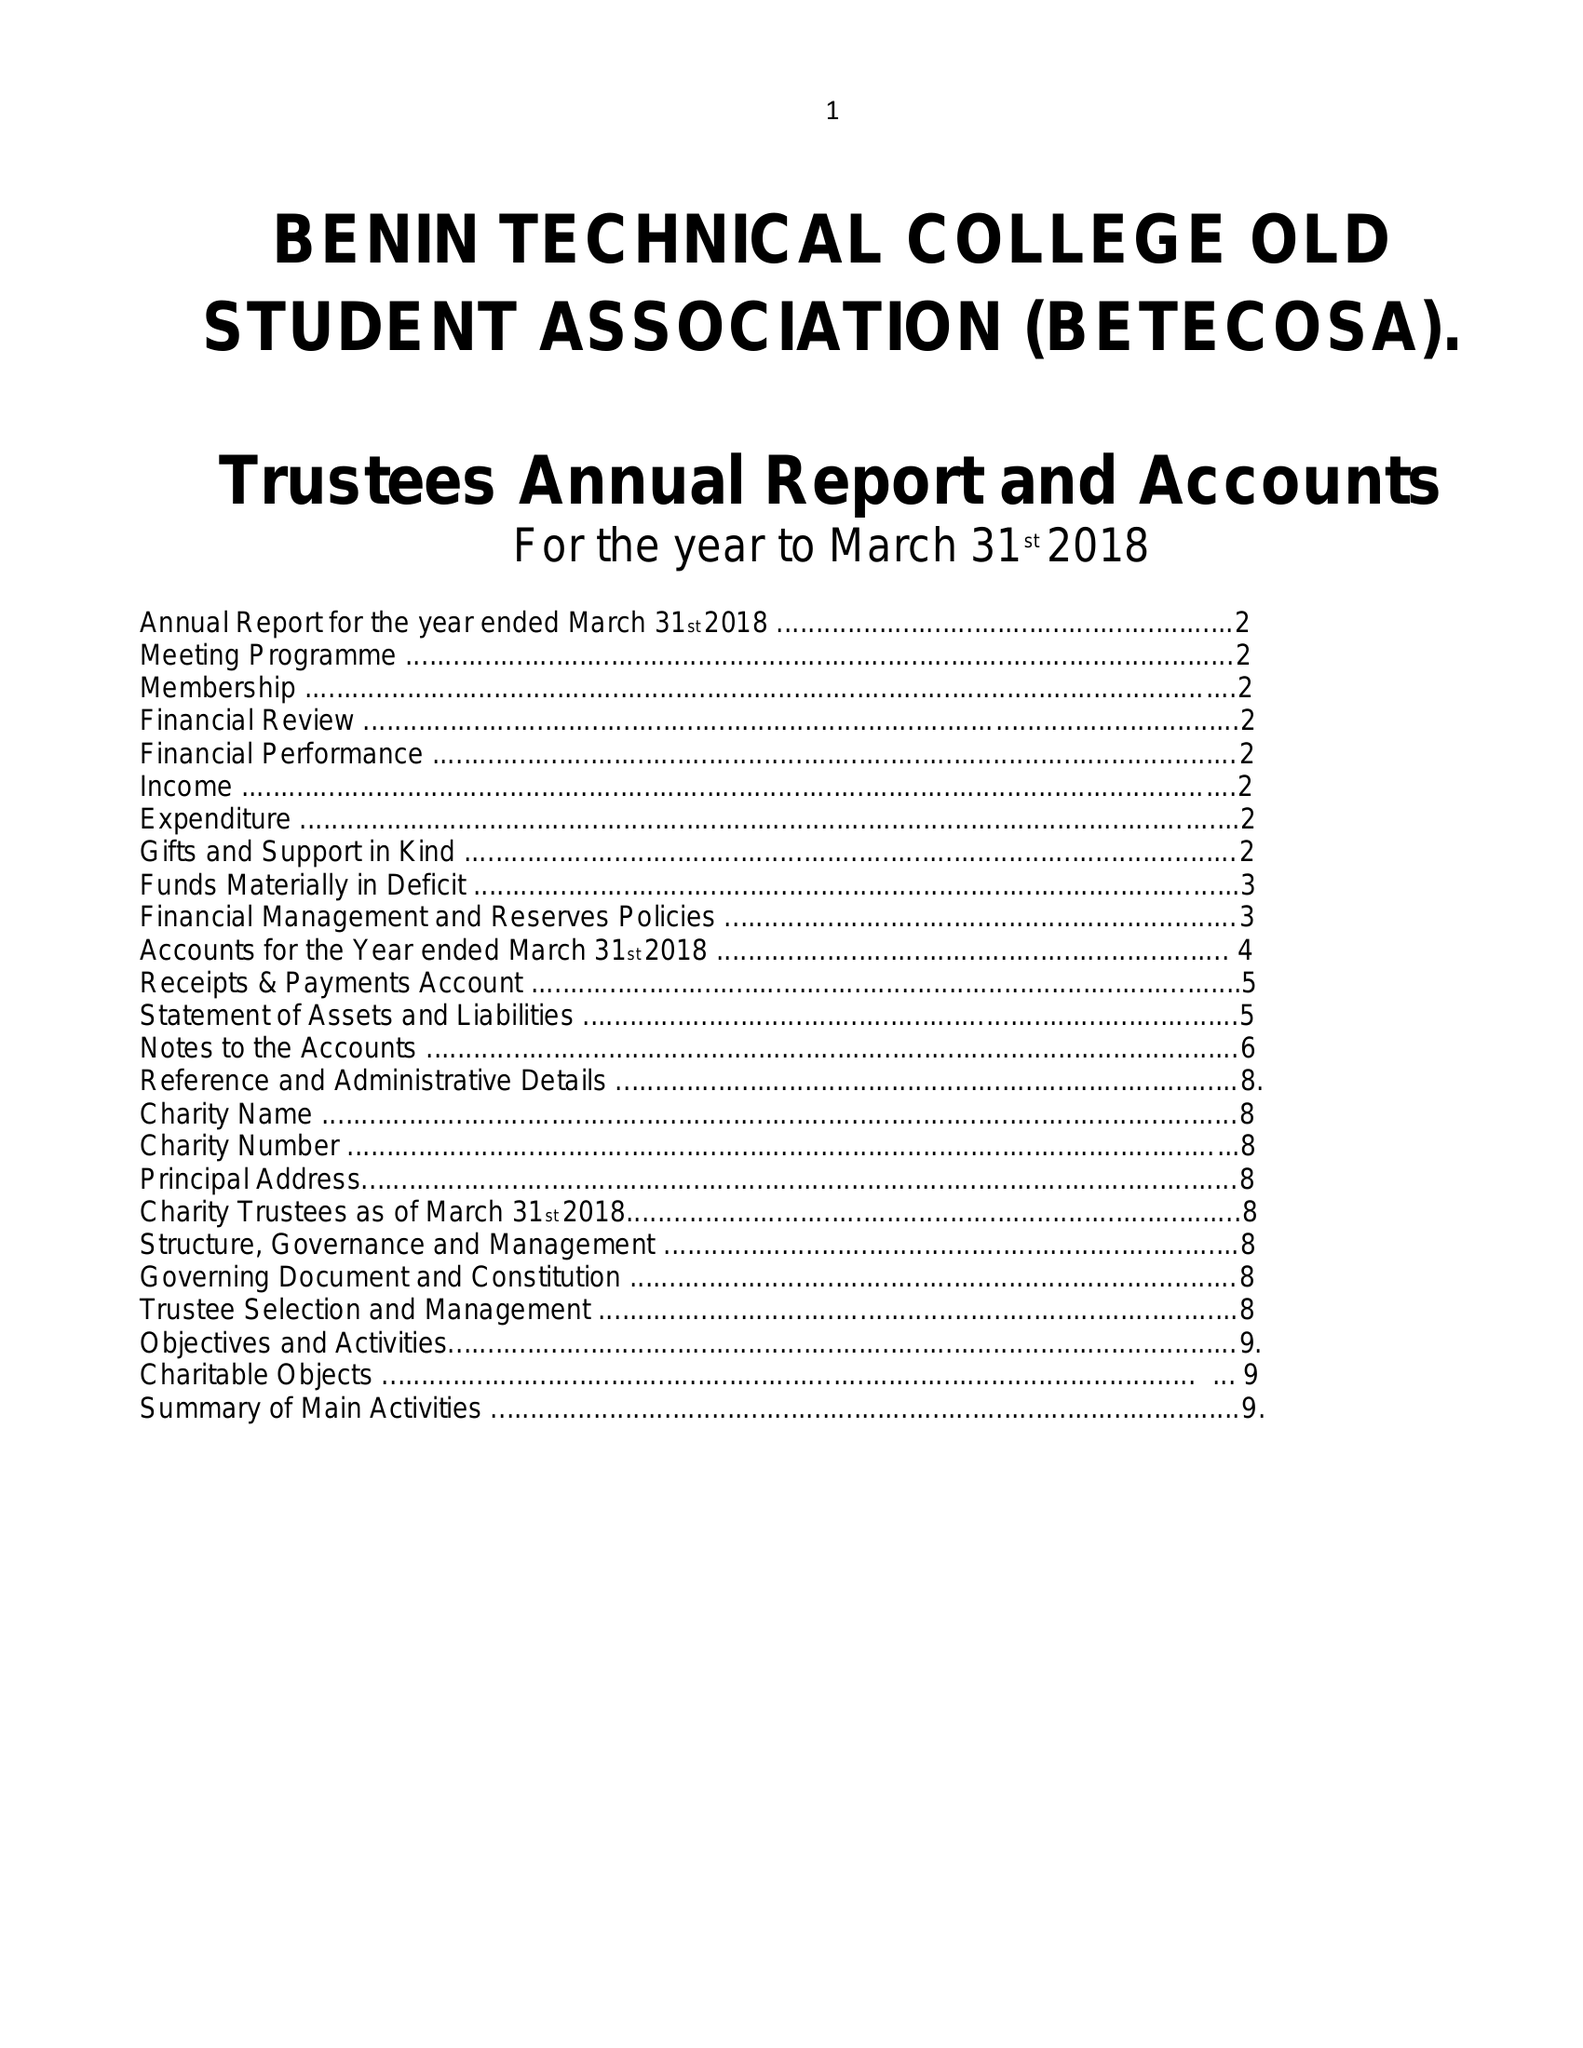What is the value for the charity_name?
Answer the question using a single word or phrase. Benin Technical College Old Student Association 